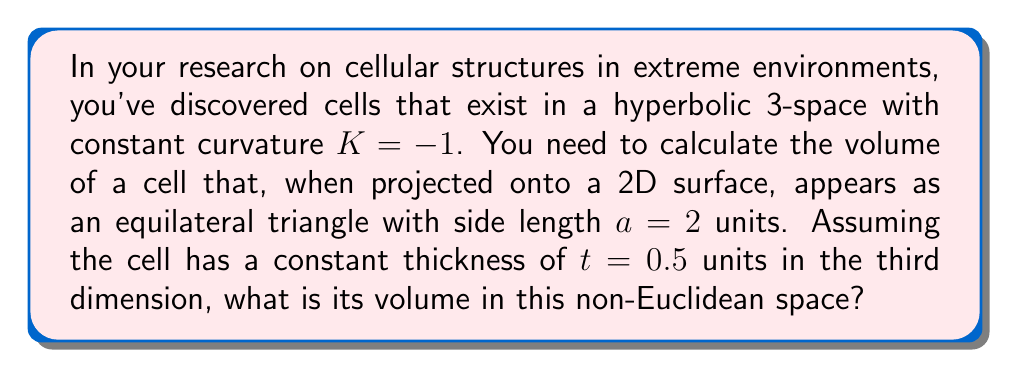Could you help me with this problem? To solve this problem, we'll follow these steps:

1) In hyperbolic geometry, the area of an equilateral triangle with side length $a$ is given by:

   $$A = 4K^{-1} \arccos\left(\frac{\cosh(a\sqrt{-K}/2)}{1+\cosh(a\sqrt{-K}/2)}\right) - \pi$$

   Where $K$ is the curvature of the space.

2) Substituting $K = -1$ and $a = 2$:

   $$A = 4 \arccos\left(\frac{\cosh(1)}{1+\cosh(1)}\right) - \pi$$

3) Calculate this:
   
   $$A \approx 4 \cdot 1.5245 - \pi \approx 4.9718$$

4) In hyperbolic space, volume doesn't simply scale linearly with thickness. Instead, we use the formula:

   $$V = A \cdot \frac{\sinh(t\sqrt{-K})}{\sqrt{-K}}$$

5) Substituting our values:

   $$V = 4.9718 \cdot \frac{\sinh(0.5\sqrt{1})}{\sqrt{1}}$$

6) Simplify:

   $$V = 4.9718 \cdot \sinh(0.5) \approx 2.5944$$

Thus, the volume of the cell in this hyperbolic space is approximately 2.5944 cubic units.
Answer: $2.5944$ cubic units 